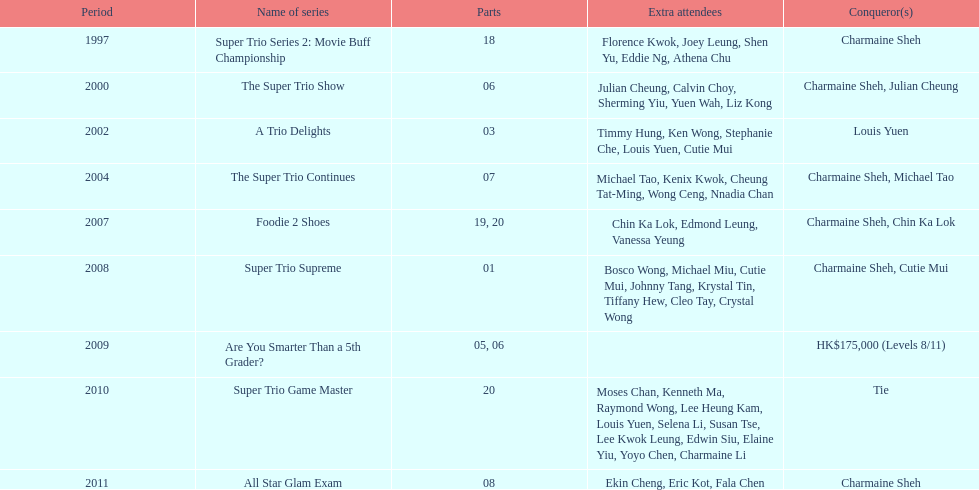How long has it been since chermaine sheh first appeared on a variety show? 17 years. 